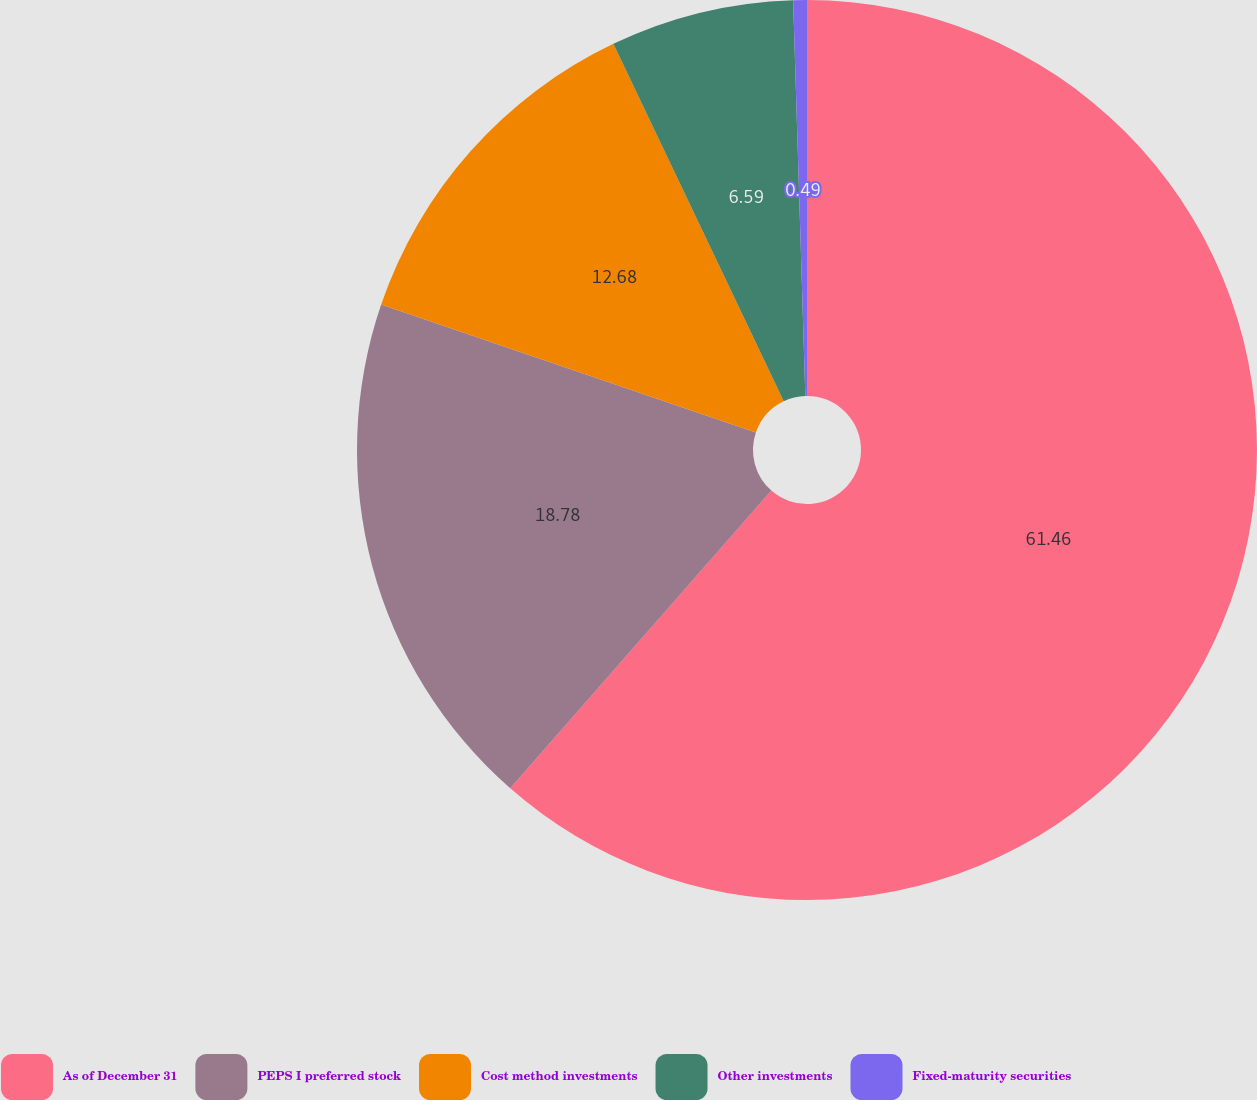Convert chart to OTSL. <chart><loc_0><loc_0><loc_500><loc_500><pie_chart><fcel>As of December 31<fcel>PEPS I preferred stock<fcel>Cost method investments<fcel>Other investments<fcel>Fixed-maturity securities<nl><fcel>61.46%<fcel>18.78%<fcel>12.68%<fcel>6.59%<fcel>0.49%<nl></chart> 